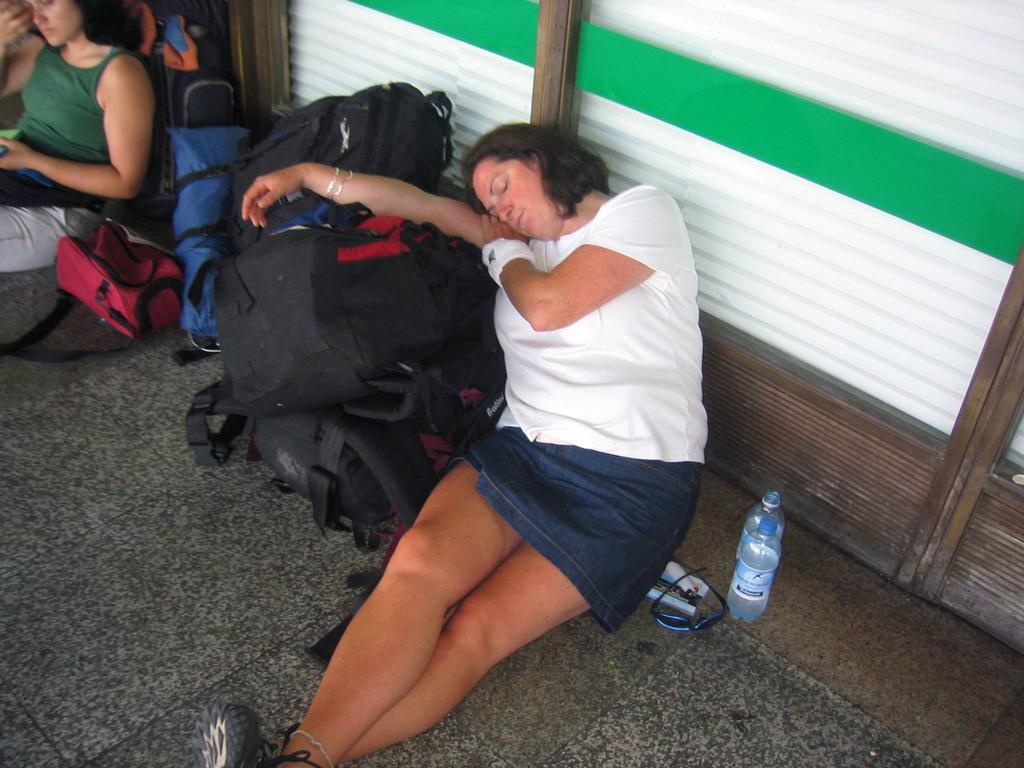Please provide a concise description of this image. In the center of the image there is a lady lying on the bags. There are bottles, glasses placed beside her. On the left there is another lady sitting. There are many backpacks. 